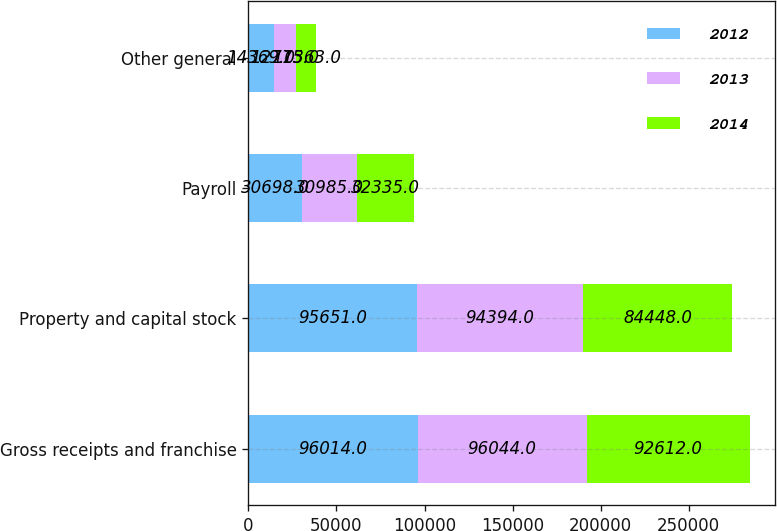Convert chart to OTSL. <chart><loc_0><loc_0><loc_500><loc_500><stacked_bar_chart><ecel><fcel>Gross receipts and franchise<fcel>Property and capital stock<fcel>Payroll<fcel>Other general<nl><fcel>2012<fcel>96014<fcel>95651<fcel>30698<fcel>14369<nl><fcel>2013<fcel>96044<fcel>94394<fcel>30985<fcel>12775<nl><fcel>2014<fcel>92612<fcel>84448<fcel>32335<fcel>11363<nl></chart> 